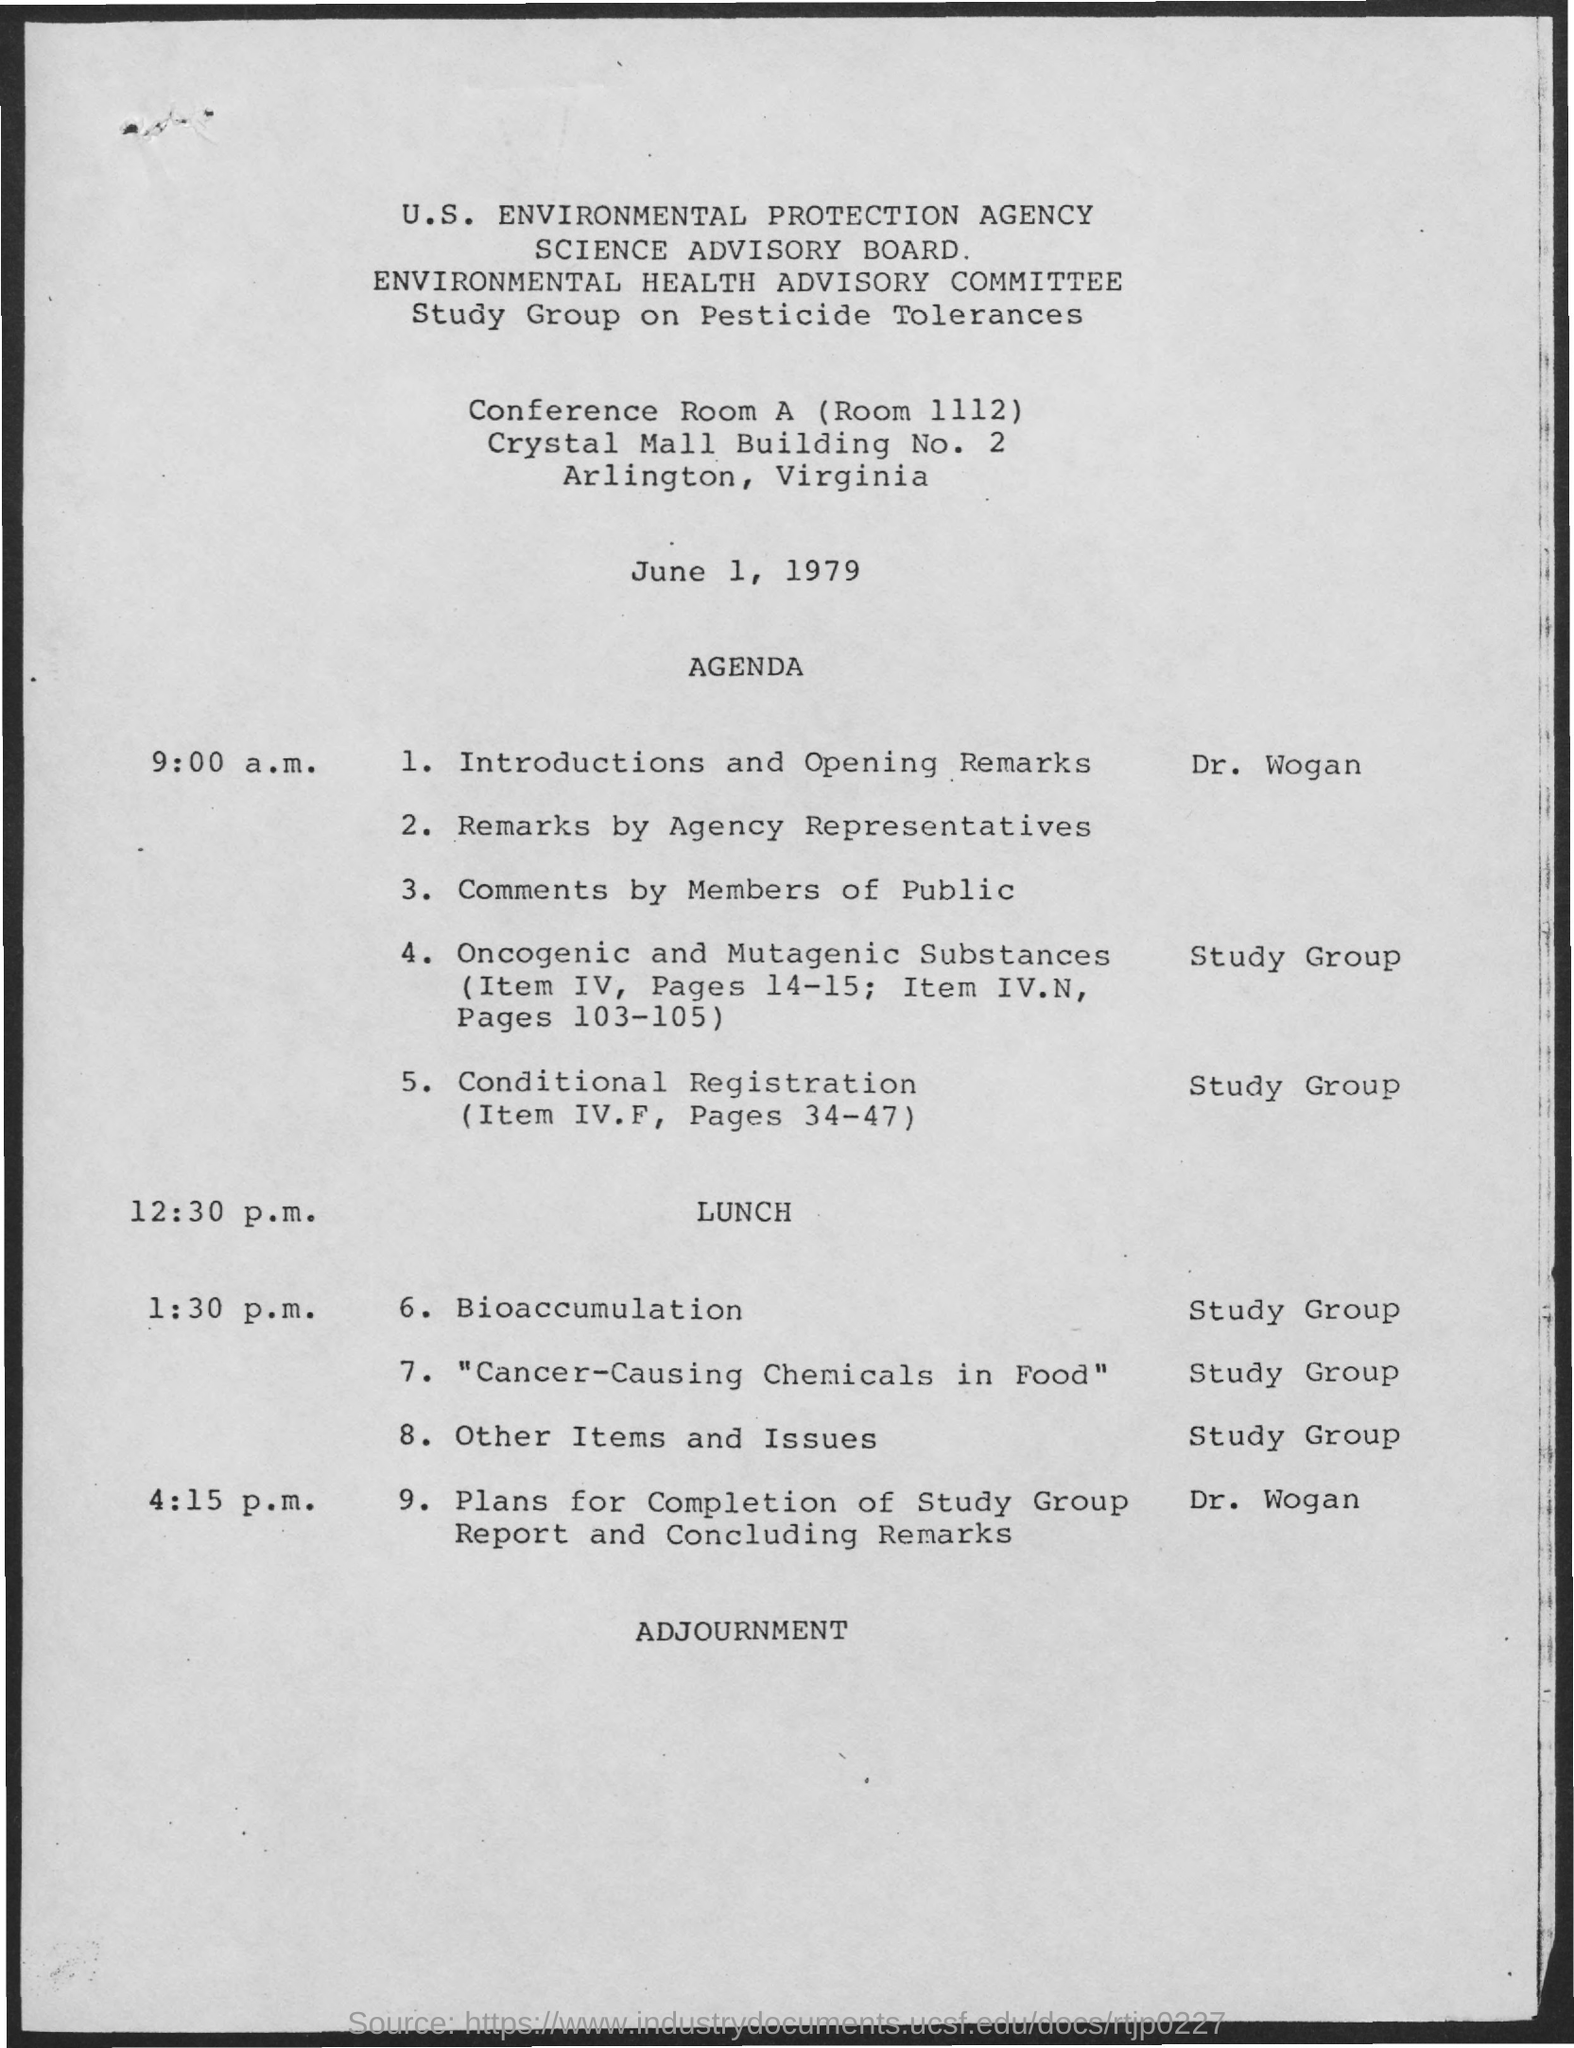Identify some key points in this picture. Lunch is at 12:30 p.m. The building number is 2. I have just provided the conference room number, which is 1112. The document indicates that the date mentioned is June 1, 1979. During the session after lunch, the topic of bioaccumulation was discussed. 